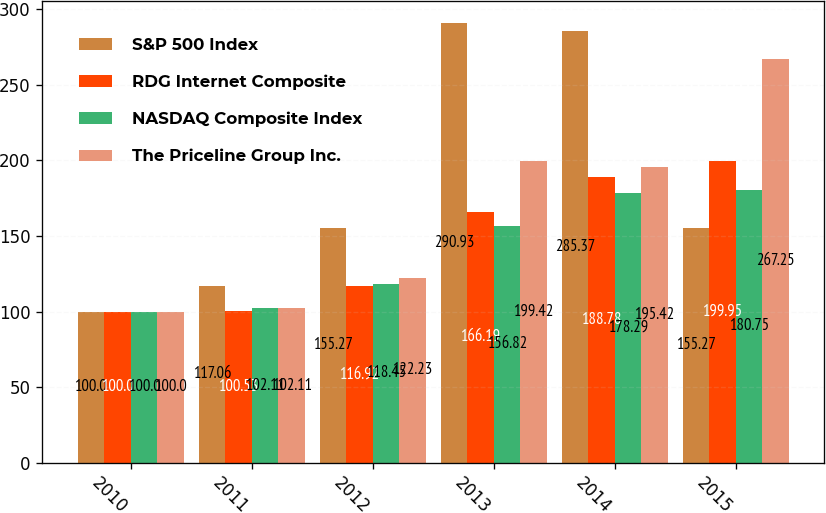Convert chart to OTSL. <chart><loc_0><loc_0><loc_500><loc_500><stacked_bar_chart><ecel><fcel>2010<fcel>2011<fcel>2012<fcel>2013<fcel>2014<fcel>2015<nl><fcel>S&P 500 Index<fcel>100<fcel>117.06<fcel>155.27<fcel>290.93<fcel>285.37<fcel>155.27<nl><fcel>RDG Internet Composite<fcel>100<fcel>100.53<fcel>116.92<fcel>166.19<fcel>188.78<fcel>199.95<nl><fcel>NASDAQ Composite Index<fcel>100<fcel>102.11<fcel>118.45<fcel>156.82<fcel>178.29<fcel>180.75<nl><fcel>The Priceline Group Inc.<fcel>100<fcel>102.11<fcel>122.23<fcel>199.42<fcel>195.42<fcel>267.25<nl></chart> 